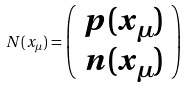<formula> <loc_0><loc_0><loc_500><loc_500>N ( x _ { \mu } ) = \left ( \begin{array} { c } p ( x _ { \mu } ) \\ n ( x _ { \mu } ) \end{array} \right )</formula> 